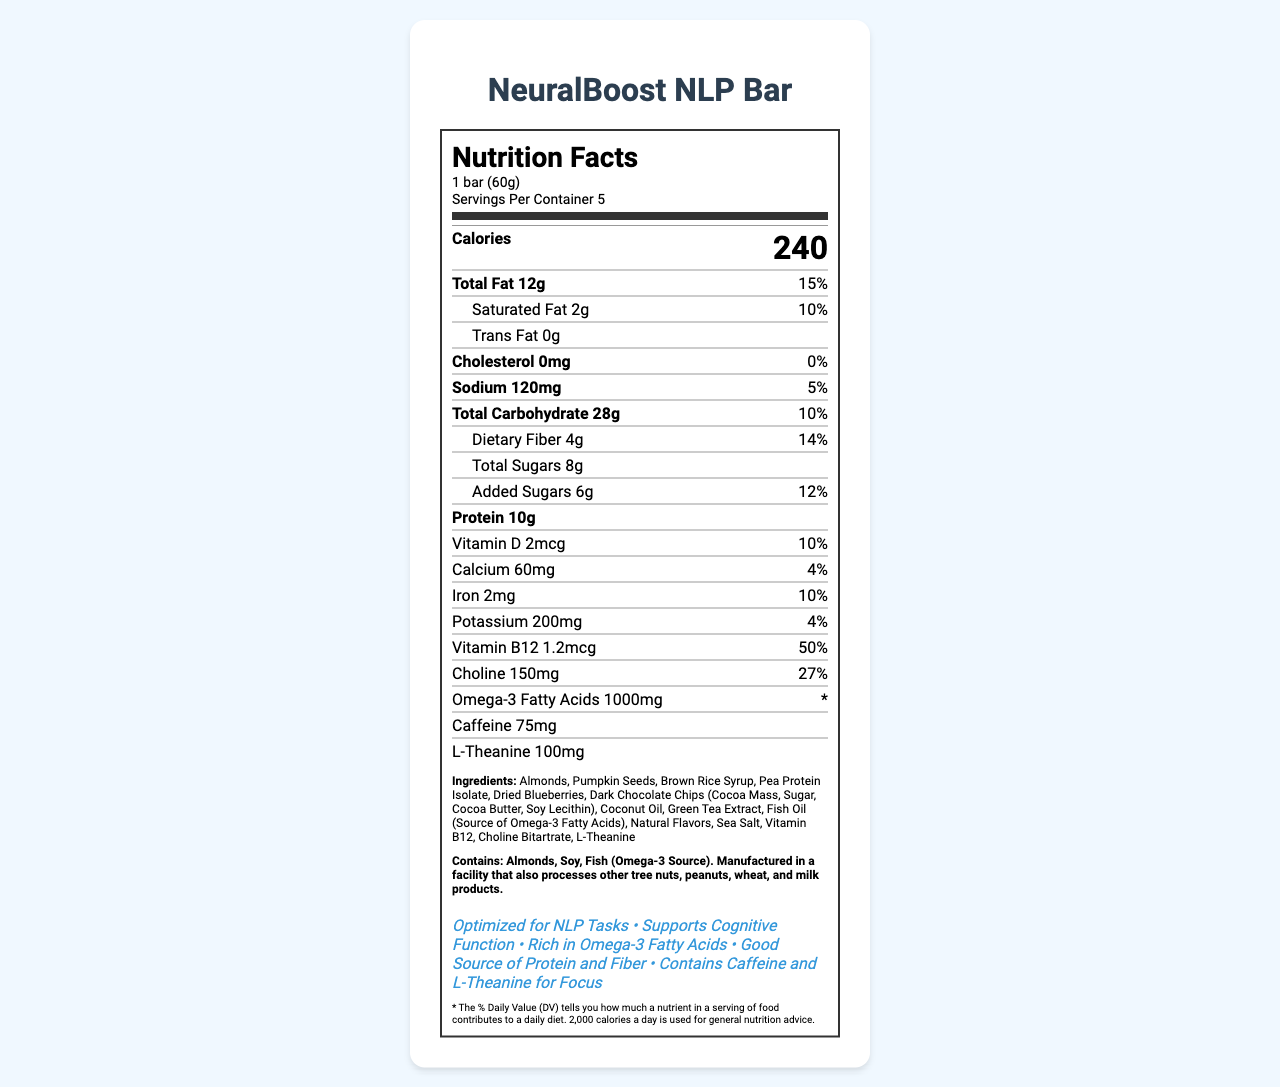what is the serving size of the NeuralBoost NLP Bar? The serving size is specified at the top of the nutrition facts label as "1 bar (60g)."
Answer: 1 bar (60g) how many servings per container are there? The label clearly states "Servings Per Container: 5."
Answer: 5 what is the calorie content per serving? The label indicates that each serving contains 240 calories.
Answer: 240 calories how much total fat does one serving contain? The amount of total fat per serving is listed as 12g.
Answer: 12g which nutrient has the highest percentage of daily value and what is it? Vitamin B12 has the highest % daily value listed at 50%.
Answer: Vitamin B12, 50% how much protein is in each serving of the NeuralBoost NLP Bar? A. 8g B. 10g C. 12g D. 15g The amount of protein per serving is listed as 10g in the nutrition facts label.
Answer: B. 10g which ingredient is not included in the NeuralBoost NLP Bar? I. Almonds II. Pumpkin Seeds III. Peanut Butter IV. Dried Blueberries The listed ingredients include Almonds, Pumpkin Seeds, Dried Blueberries, and not Peanut Butter.
Answer: III. Peanut Butter does the NeuralBoost NLP Bar contain caffeine? The nutrition facts label lists caffeine as one of the ingredients with an amount of 75mg.
Answer: Yes does the bar contain any common allergens? The allergen info on the label indicates that it contains almonds, soy, and fish (Omega-3 Source), and is manufactured in a facility that processes other tree nuts, peanuts, wheat, and milk products.
Answer: Yes describe the main idea of the document The explanation includes specific data such as serving size, nutrients, ingredients, and the overall purpose and claims of the NeuralBoost NLP Bar.
Answer: The document is a Nutrition Facts Label for the NeuralBoost NLP Bar, a brain-boosting snack optimized for natural language processing tasks. It provides information on serving size, nutrients per serving, ingredients, allergen information, and specific claims such as supporting cognitive function and being rich in Omega-3 fatty acids. what is the source of Omega-3 fatty acids in the bar? The source of Omega-3 fatty acids in the NeuralBoost NLP Bar is stated to be Fish Oil.
Answer: Fish Oil how much dietary fiber does one bar contain? The dietary fiber content per serving is listed as 4g on the label.
Answer: 4g who is the target audience for the NeuralBoost NLP Bar based on the claims? A. Athletes B. Office workers C. Students D. People interested in cognitive function support The claims on the label include "Optimized for NLP Tasks" and "Supports Cognitive Function," indicating a target audience interested in cognitive support.
Answer: D. People interested in cognitive function support what percentage of daily value is provided by the calcium content in one serving? The daily value percentage for calcium is listed as 4% on the nutrition facts label.
Answer: 4% what type of chocolate is used in the NeuralBoost NLP Bar? The ingredient list includes "Dark Chocolate Chips (Cocoa Mass, Sugar, Cocoa Butter, Soy Lecithin)."
Answer: Dark Chocolate Chips is the NeuralBoost NLP Bar free from added sugars? The label indicates that the bar contains added sugars, with an amount of 6g or 12% of the daily value.
Answer: No how much L-Theanine is in each bar of NeuralBoost NLP Bar? The amount of L-Theanine per serving is listed as 100mg.
Answer: 100mg what are the comparable claims made about the NeuralBoost NLP Bar? The label claims that the bar contains caffeine and L-Theanine, which are commonly known for improving focus.
Answer: Contains Caffeine and L-Theanine for Focus does the label specify the exact types of vitamin and nutrients included in the bar? The label lists specific vitamins and nutrients such as Vitamin D, Calcium, Iron, Potassium, Vitamin B12, and Choline.
Answer: Yes can the document determine the suggested retail price of the NeuralBoost NLP Bar? The label does not provide any information about the price of the product.
Answer: Not enough information 